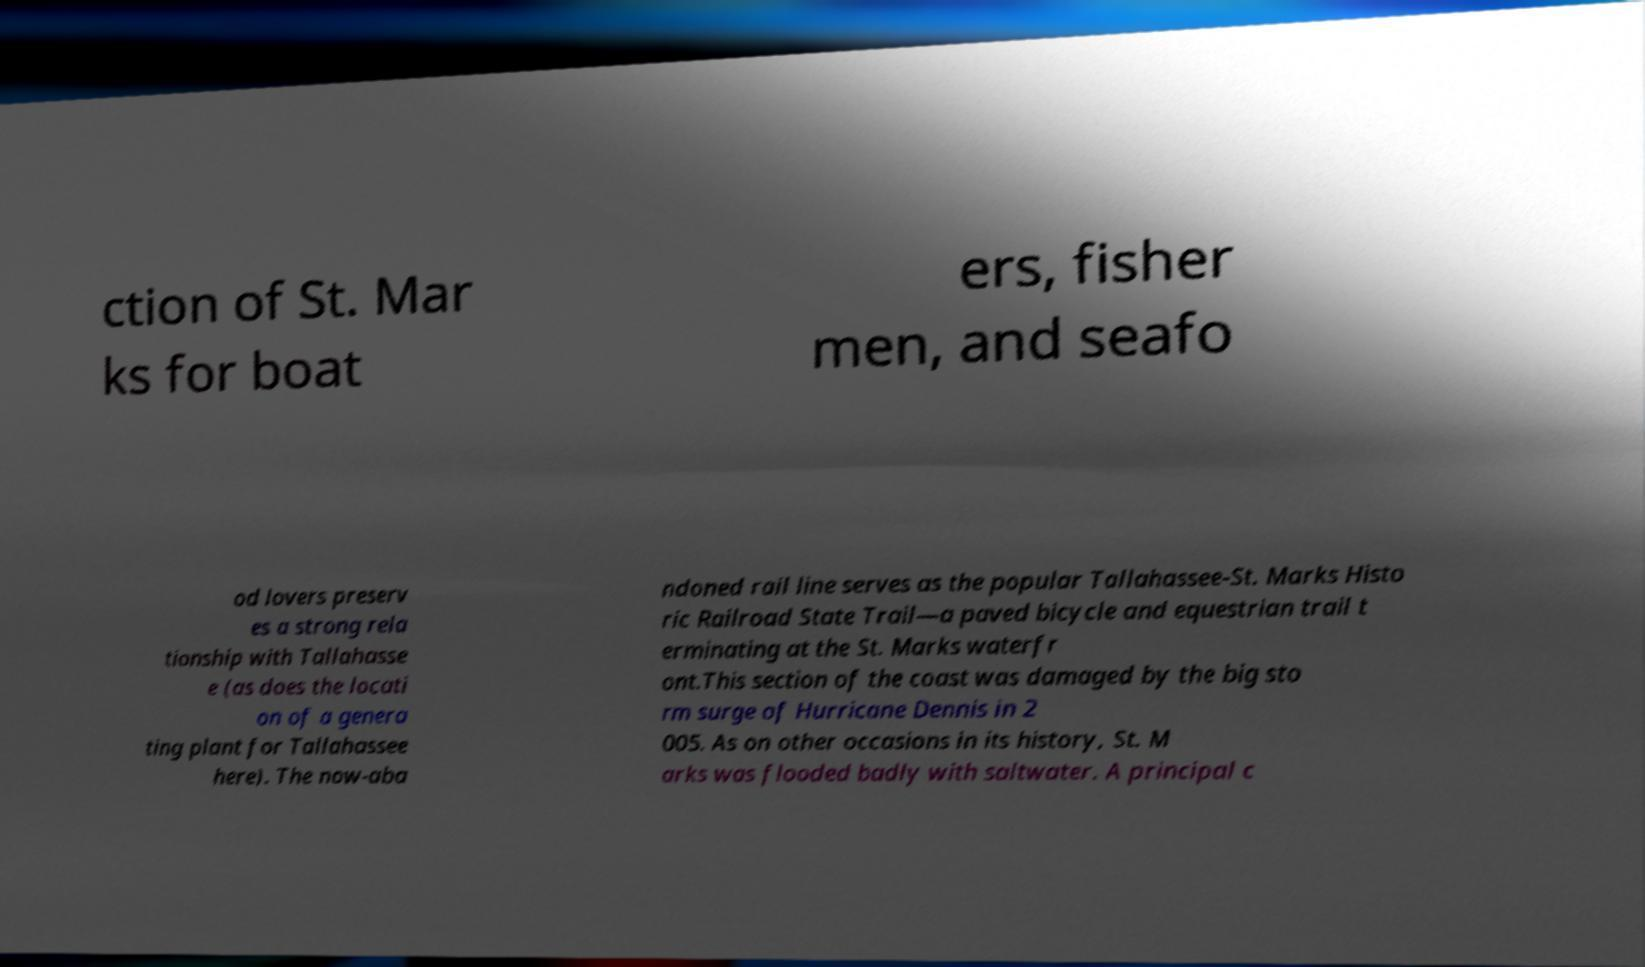Could you assist in decoding the text presented in this image and type it out clearly? ction of St. Mar ks for boat ers, fisher men, and seafo od lovers preserv es a strong rela tionship with Tallahasse e (as does the locati on of a genera ting plant for Tallahassee here). The now-aba ndoned rail line serves as the popular Tallahassee-St. Marks Histo ric Railroad State Trail—a paved bicycle and equestrian trail t erminating at the St. Marks waterfr ont.This section of the coast was damaged by the big sto rm surge of Hurricane Dennis in 2 005. As on other occasions in its history, St. M arks was flooded badly with saltwater. A principal c 